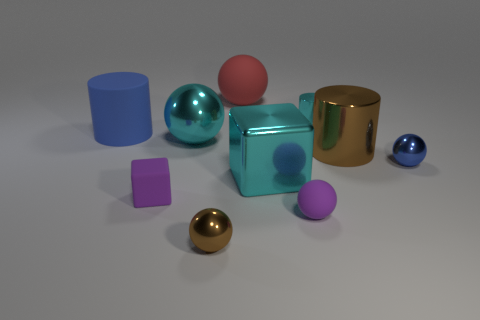Subtract all blue matte things. Subtract all cyan objects. How many objects are left? 6 Add 2 blue rubber things. How many blue rubber things are left? 3 Add 8 small blue metal things. How many small blue metal things exist? 9 Subtract all cyan balls. How many balls are left? 4 Subtract all rubber spheres. How many spheres are left? 3 Subtract 1 brown spheres. How many objects are left? 9 Subtract all blocks. How many objects are left? 8 Subtract 3 balls. How many balls are left? 2 Subtract all cyan balls. Subtract all red cylinders. How many balls are left? 4 Subtract all purple cylinders. How many purple cubes are left? 1 